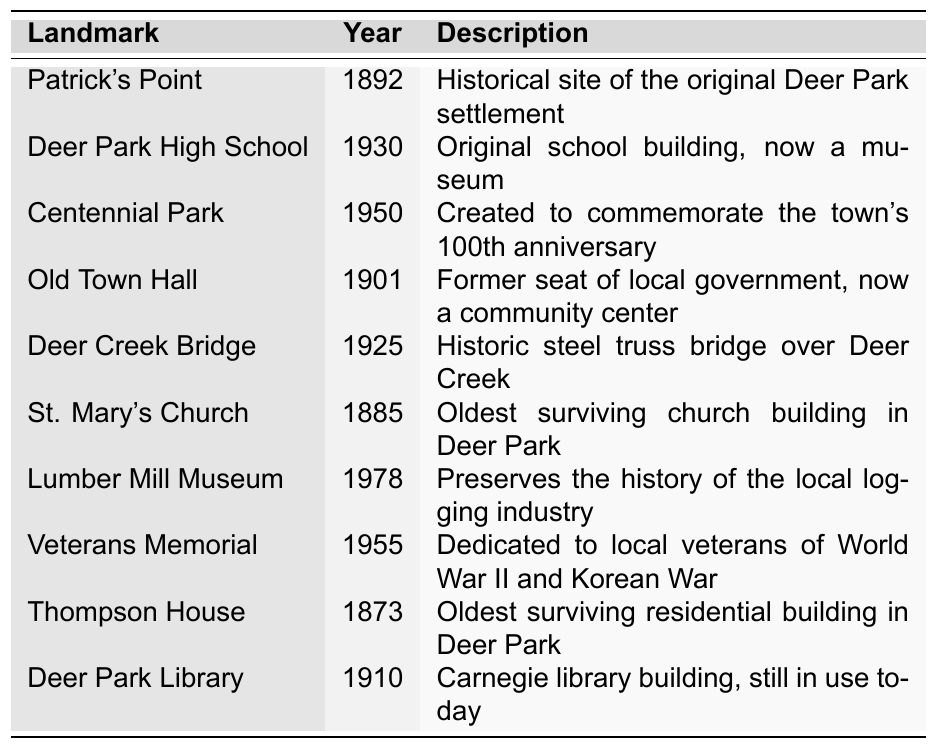What year was St. Mary's Church established? The table lists the year established for St. Mary's Church as 1885.
Answer: 1885 Which landmark was established in 1950? Looking at the table, Centennial Park is the landmark established in 1950.
Answer: Centennial Park Is Deer Park High School older than the Veterans Memorial? Deer Park High School was established in 1930 and the Veterans Memorial in 1955. Since 1930 is before 1955, Deer Park High School is older.
Answer: Yes How many landmarks were established before 1900? By examining the years established, the landmarks before 1900 are Patrick's Point (1892), St. Mary's Church (1885), and Thompson House (1873), totaling three landmarks.
Answer: 3 Which landmark has the longest history, and what year was it established? The Thompson House was established in 1873, making it the oldest landmark in the table.
Answer: Thompson House, 1873 What is the average year of establishment for all the landmarks listed? To find the average, sum all the years: 1892 + 1930 + 1950 + 1901 + 1925 + 1885 + 1978 + 1955 + 1873 + 1910 = 19,271. There are 10 landmarks, so the average is 19,271 / 10 = 1927.1, rounding gives 1927.
Answer: 1927 Are there more landmarks established in the 20th century or the 19th century? The landmarks established in the 19th century are Patrick's Point (1892), St. Mary's Church (1885), and Thompson House (1873) totaling three. In the 20th century, there are Deer Park High School (1930), Centennial Park (1950), Deer Creek Bridge (1925), Lumber Mill Museum (1978), Veterans Memorial (1955), and Deer Park Library (1910), totaling seven. Since 7 > 3, there are more in the 20th century.
Answer: 20th century What landmark is associated with the original Deer Park settlement? The landmark associated with the original Deer Park settlement is Patrick's Point.
Answer: Patrick's Point What is the description of the Deer Park Library? According to the table, the Deer Park Library is described as a Carnegie library building, still in use today.
Answer: Carnegie library building, still in use today Which two landmarks were established in the same decade? Upon reviewing the years, Deer Park High School (1930) and Deer Creek Bridge (1925) were established within the 1920s and 1930s; they both fit into the same decade of the 1920s and 1930s.
Answer: Deer Park High School and Deer Creek Bridge 